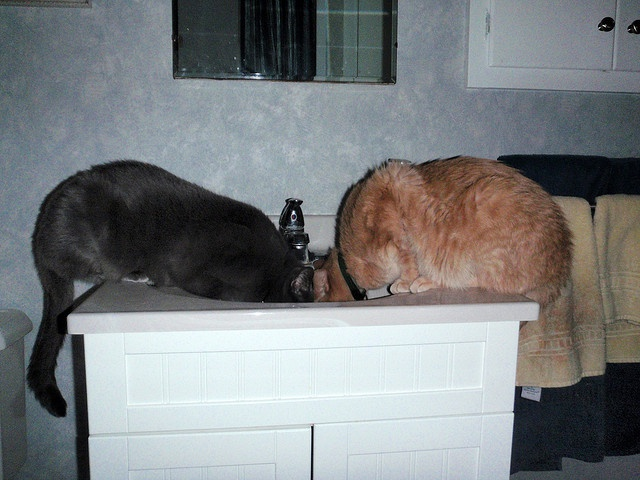Describe the objects in this image and their specific colors. I can see cat in black, gray, and darkgray tones, cat in black, gray, brown, and maroon tones, toilet in black and purple tones, and sink in black, maroon, gray, and darkgray tones in this image. 